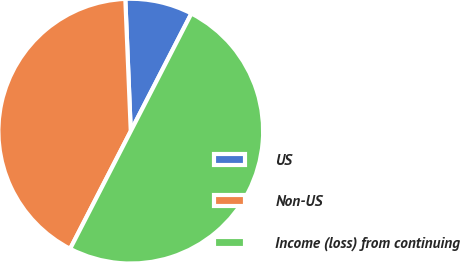Convert chart to OTSL. <chart><loc_0><loc_0><loc_500><loc_500><pie_chart><fcel>US<fcel>Non-US<fcel>Income (loss) from continuing<nl><fcel>8.23%<fcel>41.77%<fcel>50.0%<nl></chart> 